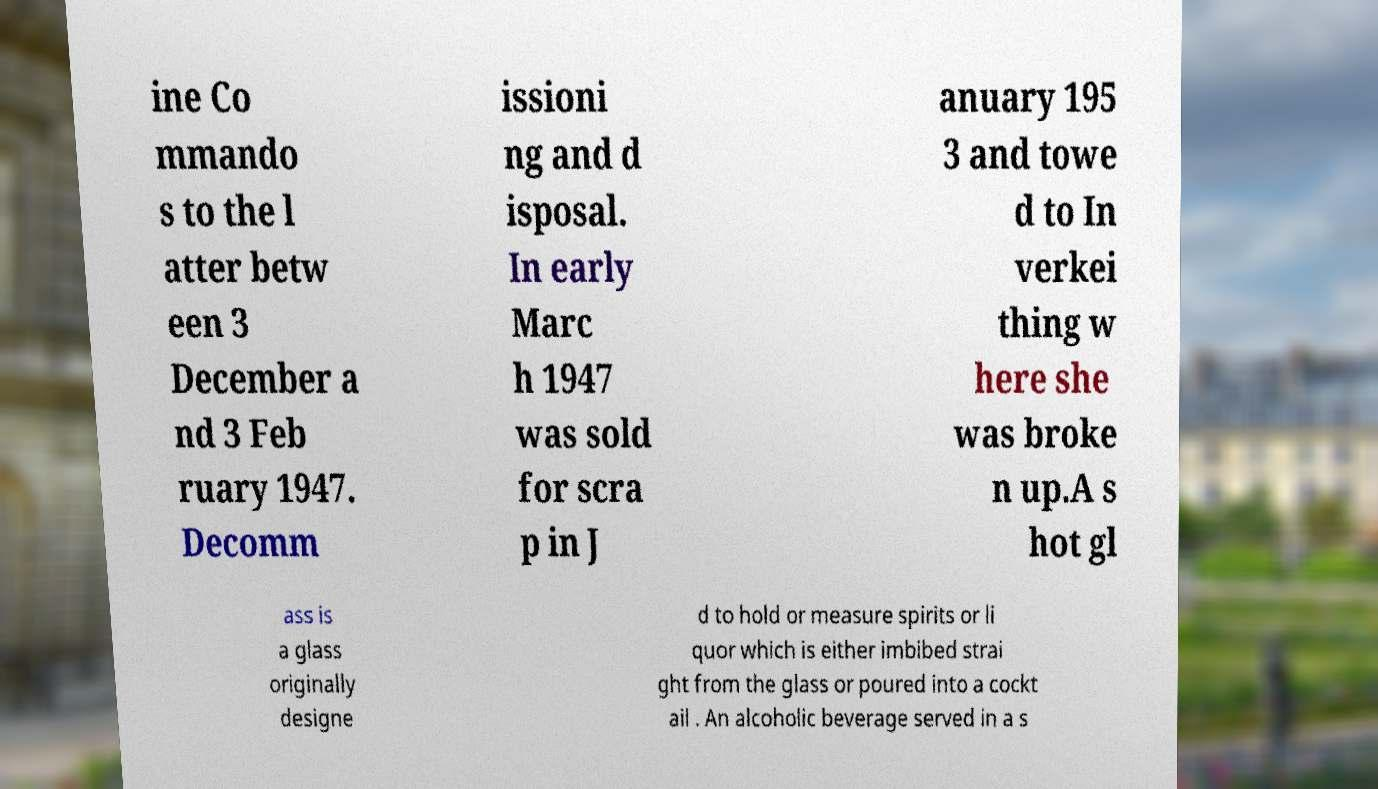There's text embedded in this image that I need extracted. Can you transcribe it verbatim? ine Co mmando s to the l atter betw een 3 December a nd 3 Feb ruary 1947. Decomm issioni ng and d isposal. In early Marc h 1947 was sold for scra p in J anuary 195 3 and towe d to In verkei thing w here she was broke n up.A s hot gl ass is a glass originally designe d to hold or measure spirits or li quor which is either imbibed strai ght from the glass or poured into a cockt ail . An alcoholic beverage served in a s 